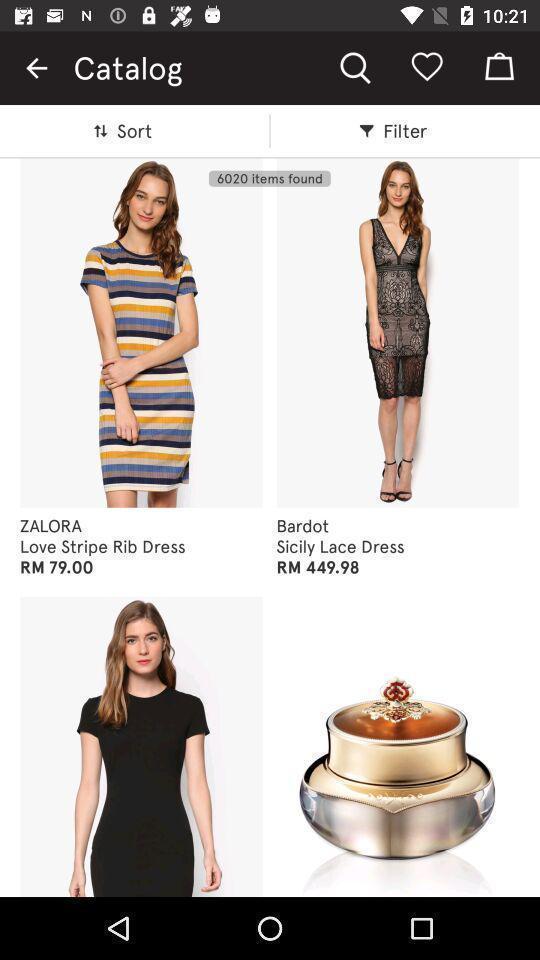What can you discern from this picture? Screen shows dresses in a shopping app. 